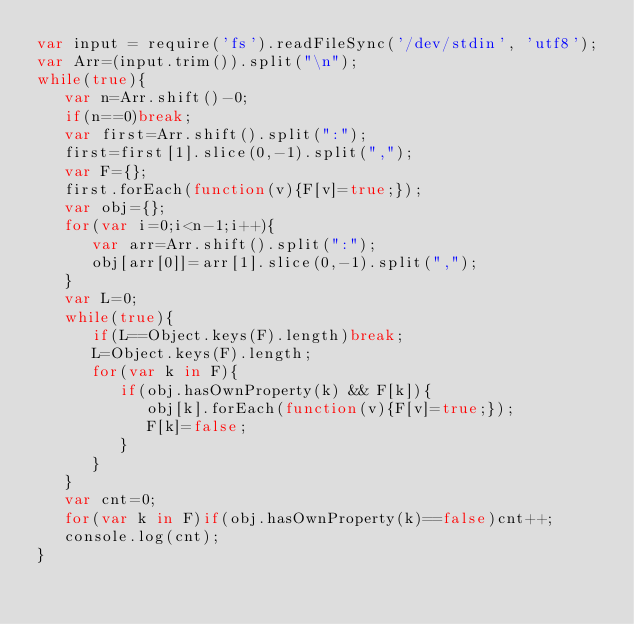<code> <loc_0><loc_0><loc_500><loc_500><_JavaScript_>var input = require('fs').readFileSync('/dev/stdin', 'utf8');
var Arr=(input.trim()).split("\n");
while(true){
   var n=Arr.shift()-0;
   if(n==0)break;
   var first=Arr.shift().split(":");
   first=first[1].slice(0,-1).split(",");
   var F={};
   first.forEach(function(v){F[v]=true;});
   var obj={};
   for(var i=0;i<n-1;i++){
      var arr=Arr.shift().split(":");
      obj[arr[0]]=arr[1].slice(0,-1).split(",");
   }
   var L=0;
   while(true){
      if(L==Object.keys(F).length)break;
      L=Object.keys(F).length;
      for(var k in F){
         if(obj.hasOwnProperty(k) && F[k]){
            obj[k].forEach(function(v){F[v]=true;});
            F[k]=false;
         }
      }
   }
   var cnt=0;
   for(var k in F)if(obj.hasOwnProperty(k)==false)cnt++;
   console.log(cnt);
}</code> 